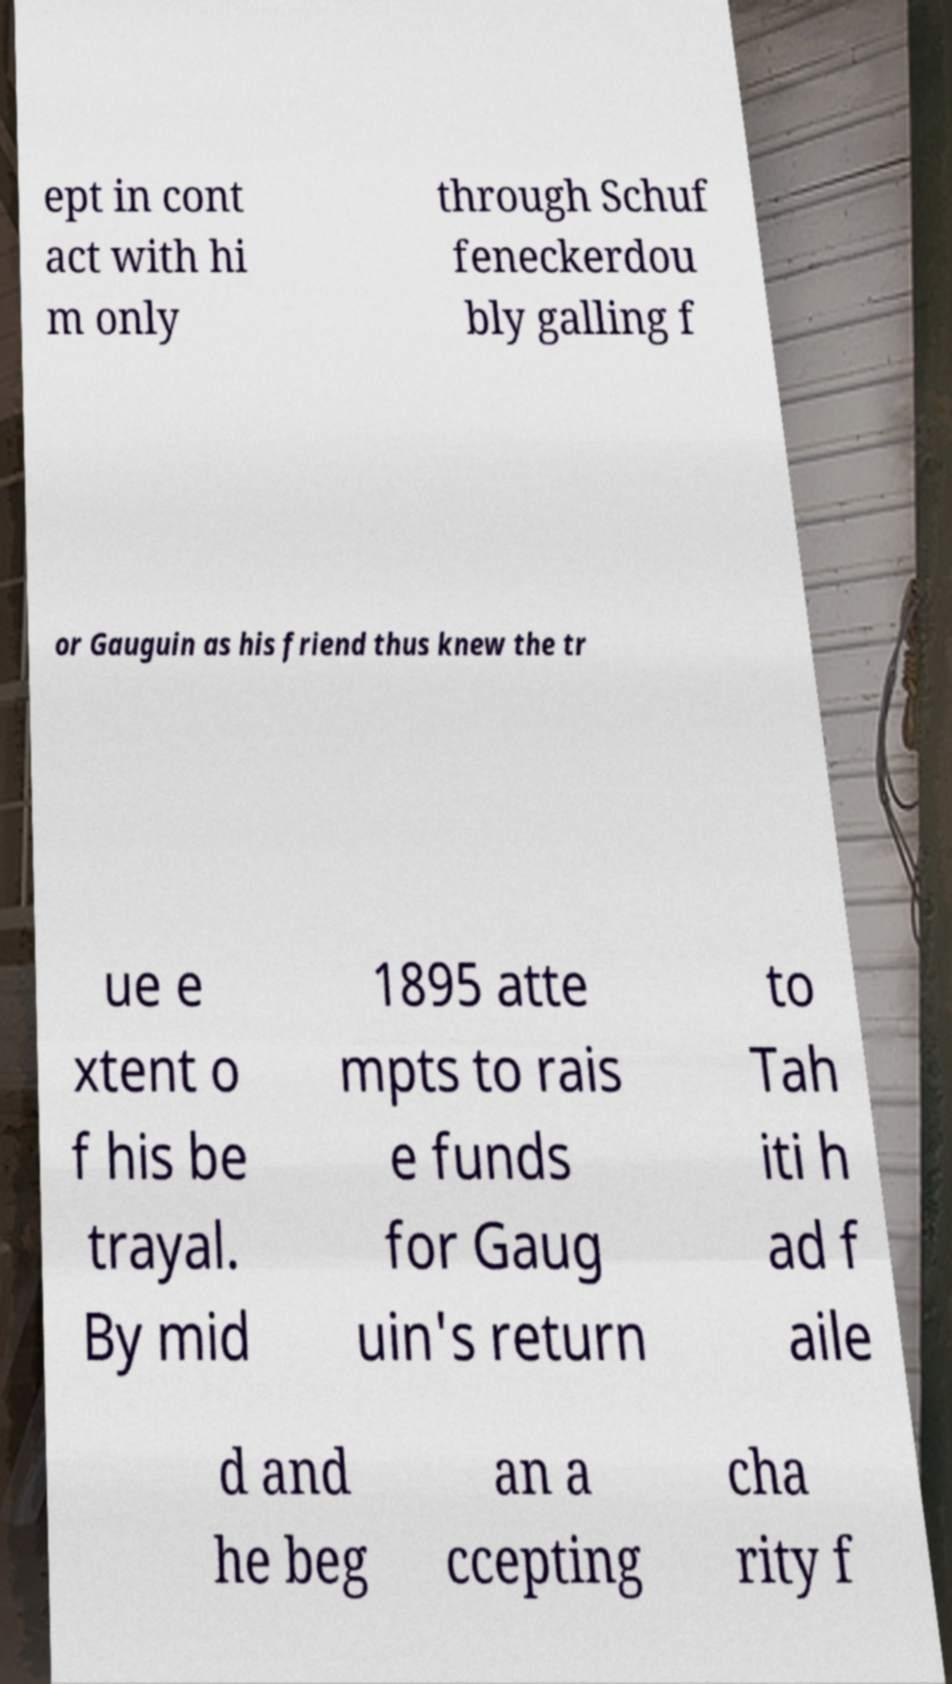Can you read and provide the text displayed in the image?This photo seems to have some interesting text. Can you extract and type it out for me? ept in cont act with hi m only through Schuf feneckerdou bly galling f or Gauguin as his friend thus knew the tr ue e xtent o f his be trayal. By mid 1895 atte mpts to rais e funds for Gaug uin's return to Tah iti h ad f aile d and he beg an a ccepting cha rity f 